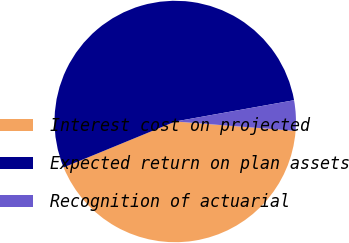<chart> <loc_0><loc_0><loc_500><loc_500><pie_chart><fcel>Interest cost on projected<fcel>Expected return on plan assets<fcel>Recognition of actuarial<nl><fcel>42.55%<fcel>53.39%<fcel>4.06%<nl></chart> 